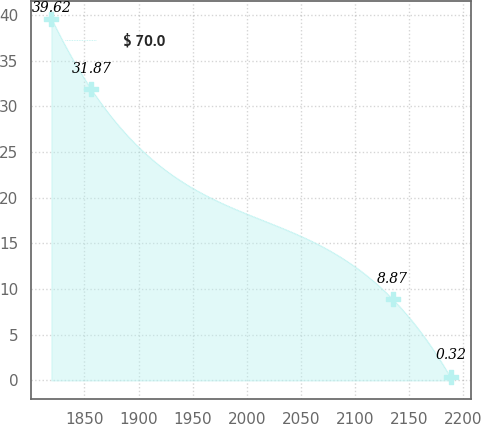Convert chart. <chart><loc_0><loc_0><loc_500><loc_500><line_chart><ecel><fcel>$ 70.0<nl><fcel>1819.48<fcel>39.62<nl><fcel>1856.36<fcel>31.87<nl><fcel>2134.85<fcel>8.87<nl><fcel>2188.23<fcel>0.32<nl></chart> 